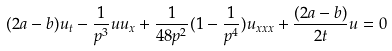<formula> <loc_0><loc_0><loc_500><loc_500>( 2 a - b ) u _ { t } - \frac { 1 } { p ^ { 3 } } u u _ { x } + \frac { 1 } { 4 8 p ^ { 2 } } ( 1 - \frac { 1 } { p ^ { 4 } } ) u _ { x x x } + \frac { ( 2 a - b ) } { 2 t } u = 0</formula> 